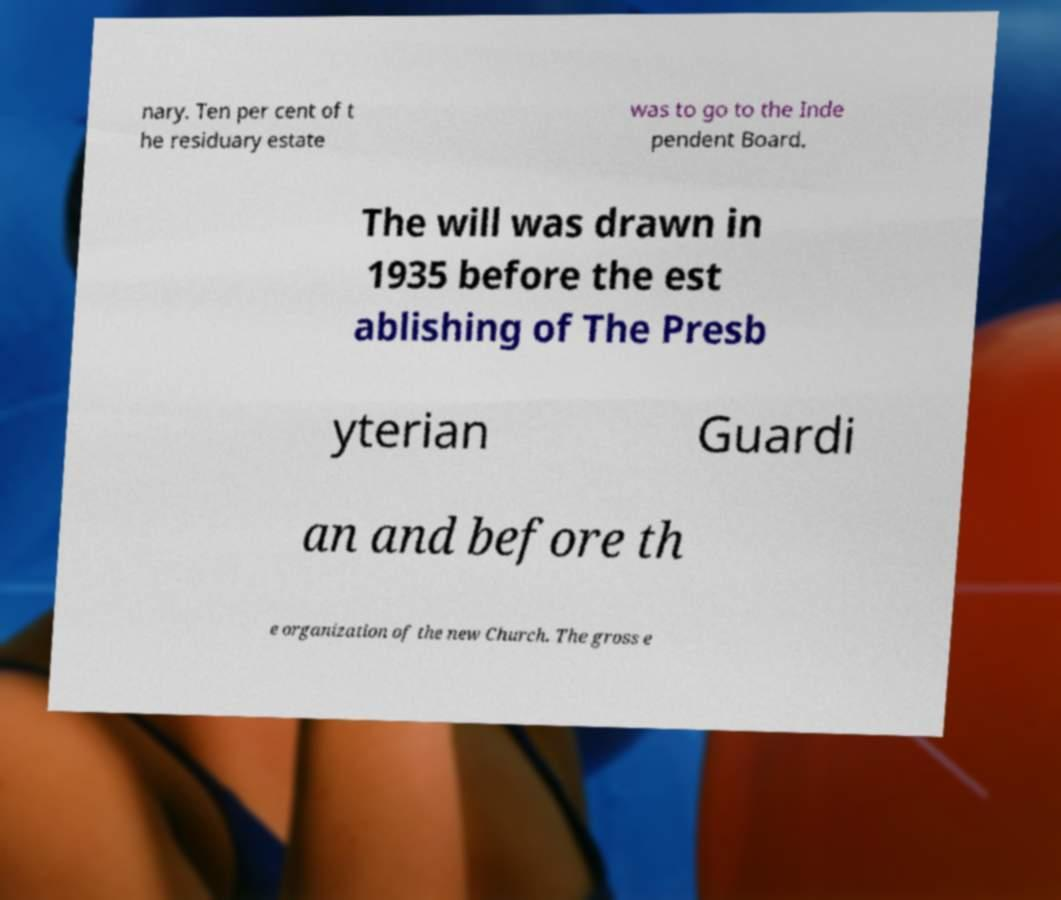What messages or text are displayed in this image? I need them in a readable, typed format. nary. Ten per cent of t he residuary estate was to go to the Inde pendent Board. The will was drawn in 1935 before the est ablishing of The Presb yterian Guardi an and before th e organization of the new Church. The gross e 